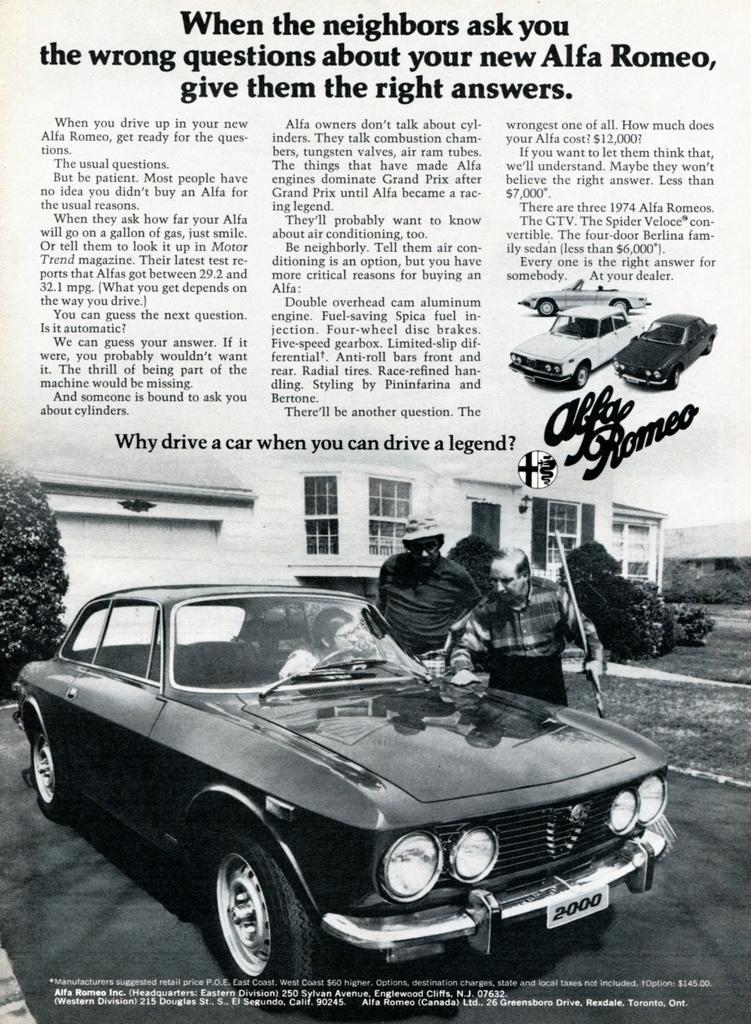Can you describe this image briefly? This is a picture of a newspaper. In the foreground there is a car. On the top there is text. 